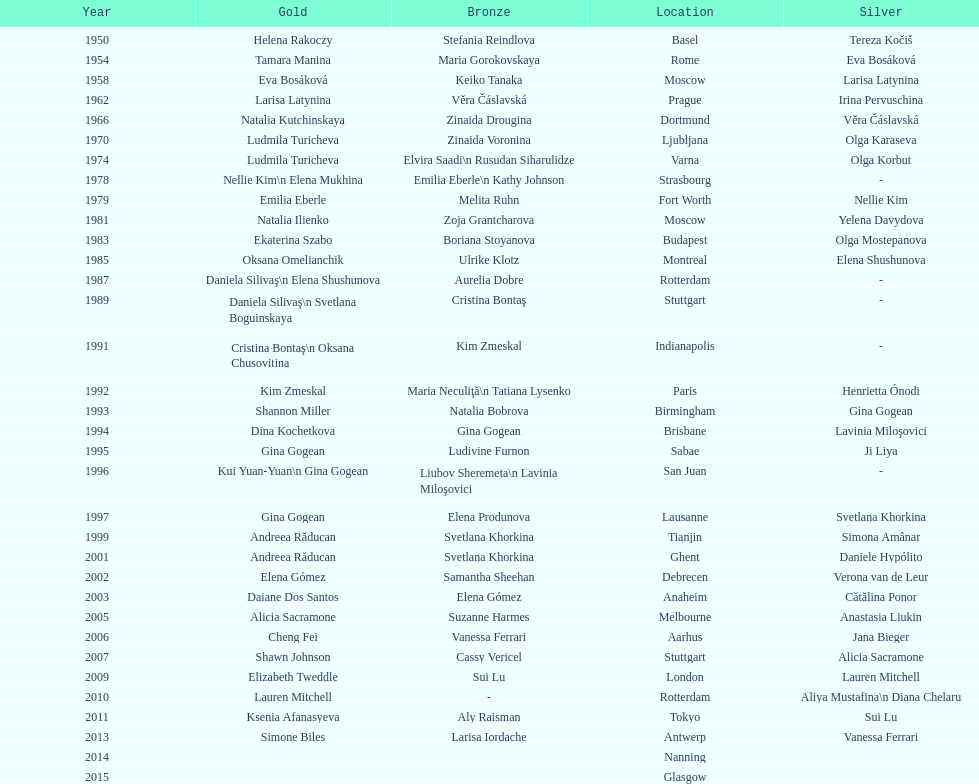What is the total number of russian gymnasts that have won silver. 8. 